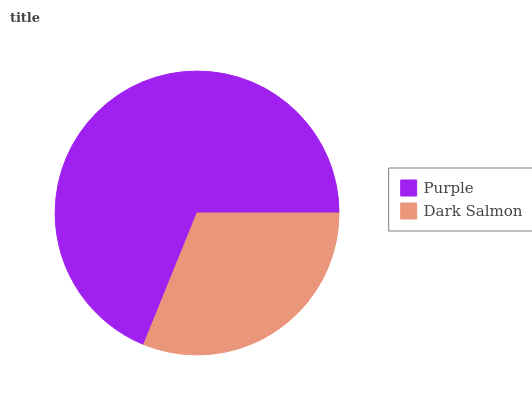Is Dark Salmon the minimum?
Answer yes or no. Yes. Is Purple the maximum?
Answer yes or no. Yes. Is Dark Salmon the maximum?
Answer yes or no. No. Is Purple greater than Dark Salmon?
Answer yes or no. Yes. Is Dark Salmon less than Purple?
Answer yes or no. Yes. Is Dark Salmon greater than Purple?
Answer yes or no. No. Is Purple less than Dark Salmon?
Answer yes or no. No. Is Purple the high median?
Answer yes or no. Yes. Is Dark Salmon the low median?
Answer yes or no. Yes. Is Dark Salmon the high median?
Answer yes or no. No. Is Purple the low median?
Answer yes or no. No. 